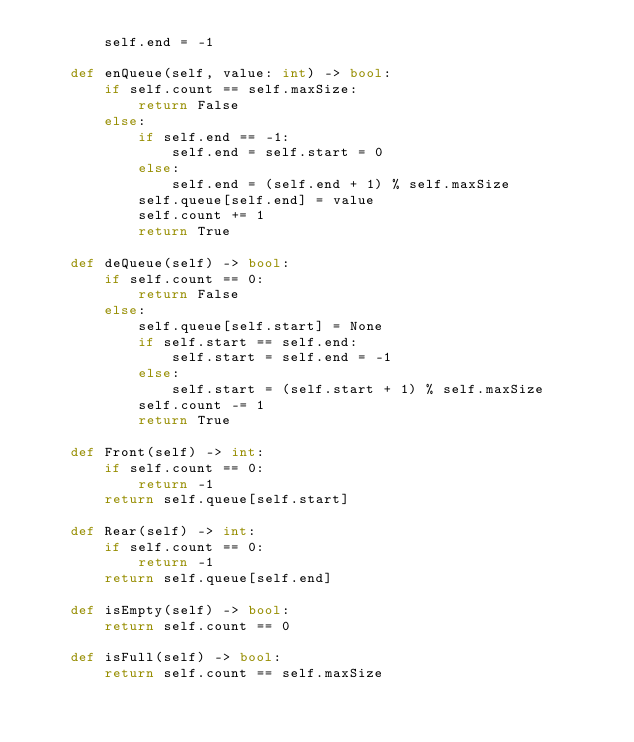<code> <loc_0><loc_0><loc_500><loc_500><_Python_>        self.end = -1

    def enQueue(self, value: int) -> bool:
        if self.count == self.maxSize:
            return False
        else:
            if self.end == -1:
                self.end = self.start = 0
            else:
                self.end = (self.end + 1) % self.maxSize
            self.queue[self.end] = value
            self.count += 1
            return True

    def deQueue(self) -> bool:
        if self.count == 0:
            return False
        else:
            self.queue[self.start] = None
            if self.start == self.end:
                self.start = self.end = -1
            else:
                self.start = (self.start + 1) % self.maxSize
            self.count -= 1
            return True

    def Front(self) -> int:
        if self.count == 0:
            return -1
        return self.queue[self.start]

    def Rear(self) -> int:
        if self.count == 0:
            return -1
        return self.queue[self.end]

    def isEmpty(self) -> bool:
        return self.count == 0

    def isFull(self) -> bool:
        return self.count == self.maxSize
</code> 